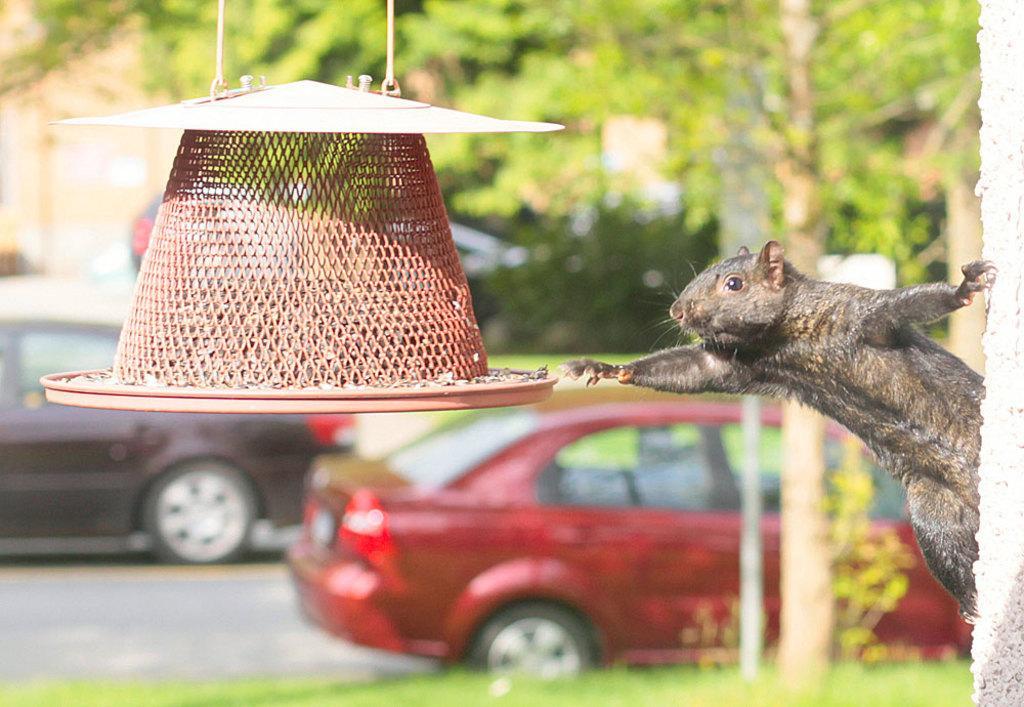Could you give a brief overview of what you see in this image? In this picture we can see a squirrel on the wall, here we can see an object and in the background we can see vehicles on the road and trees. 